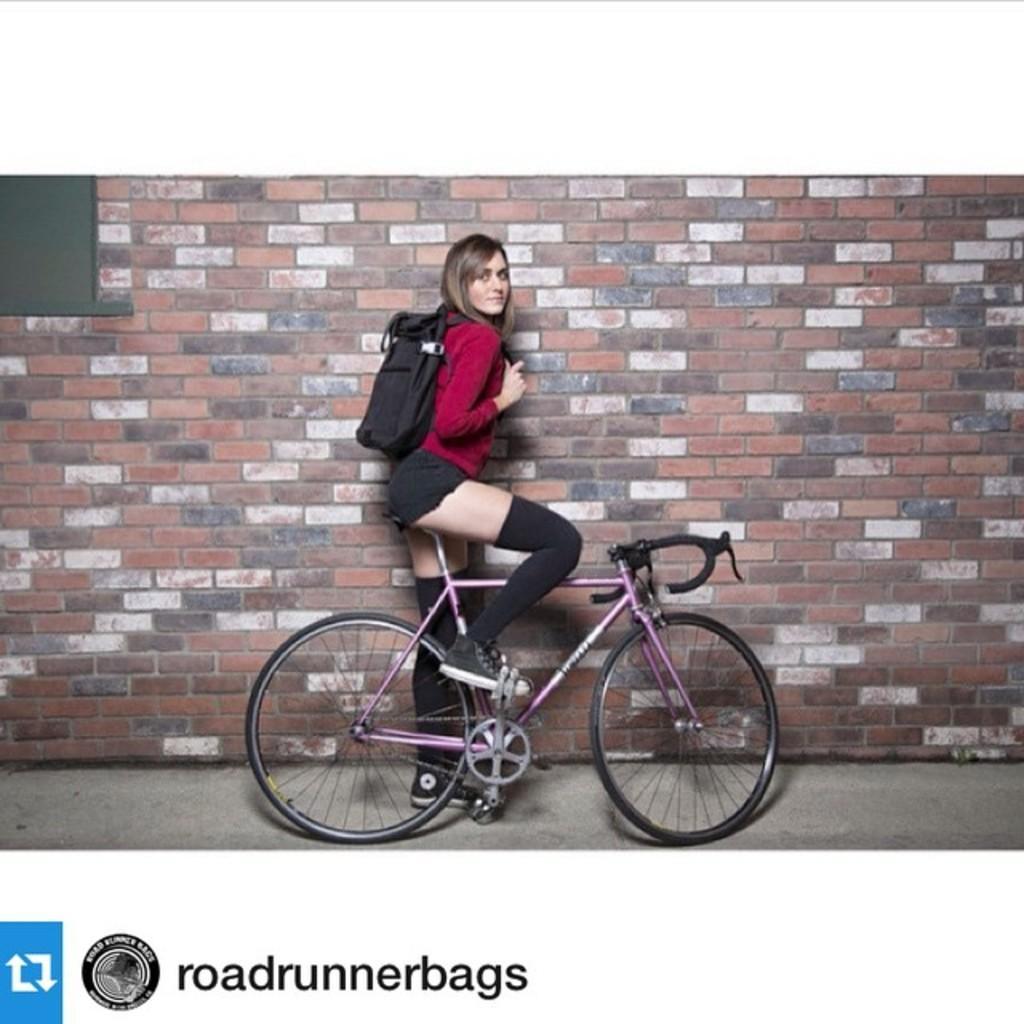How would you summarize this image in a sentence or two? In this picture there is a woman in the center,sitting on a bicycle. She is wearing a red top, black shorts, and a black bag. In the background there is a brick wall and to the left bottom there is a text. 